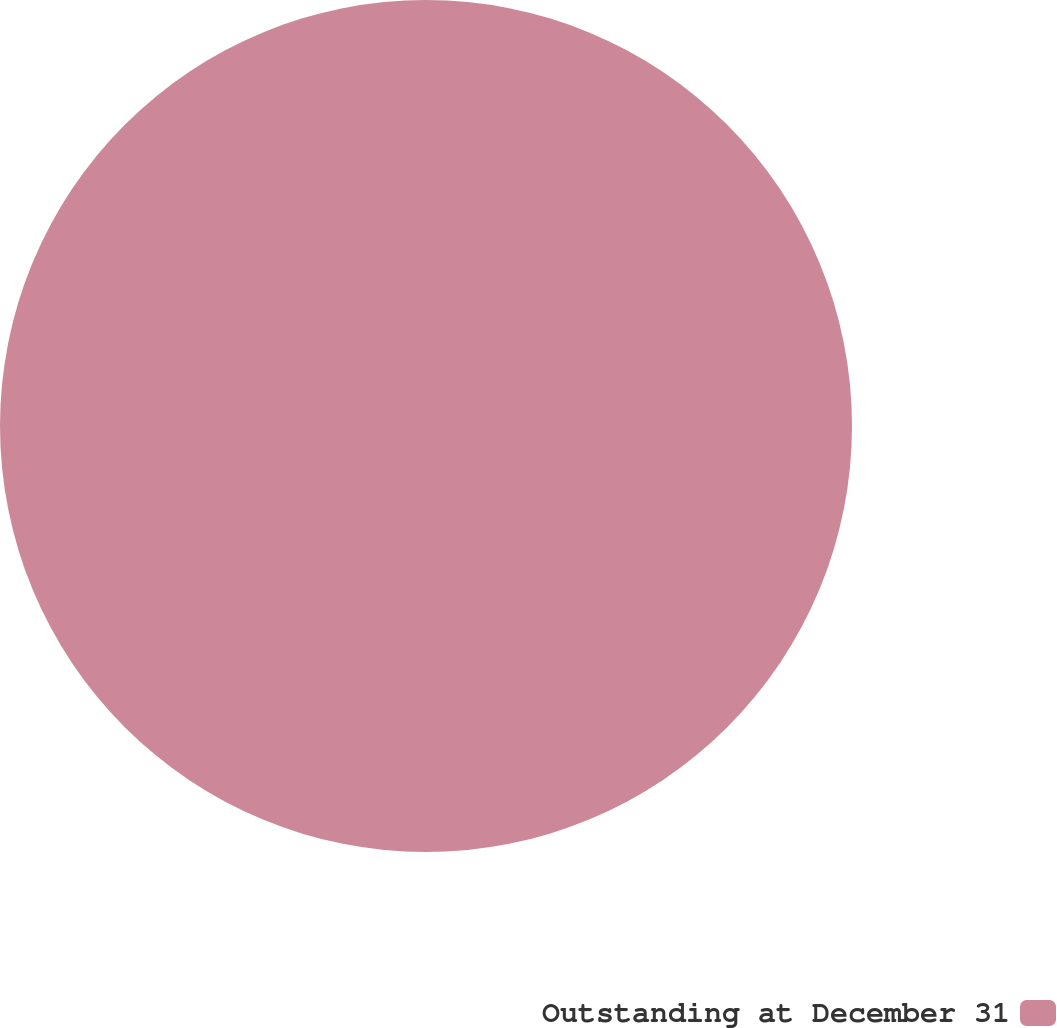Convert chart. <chart><loc_0><loc_0><loc_500><loc_500><pie_chart><fcel>Outstanding at December 31<nl><fcel>100.0%<nl></chart> 